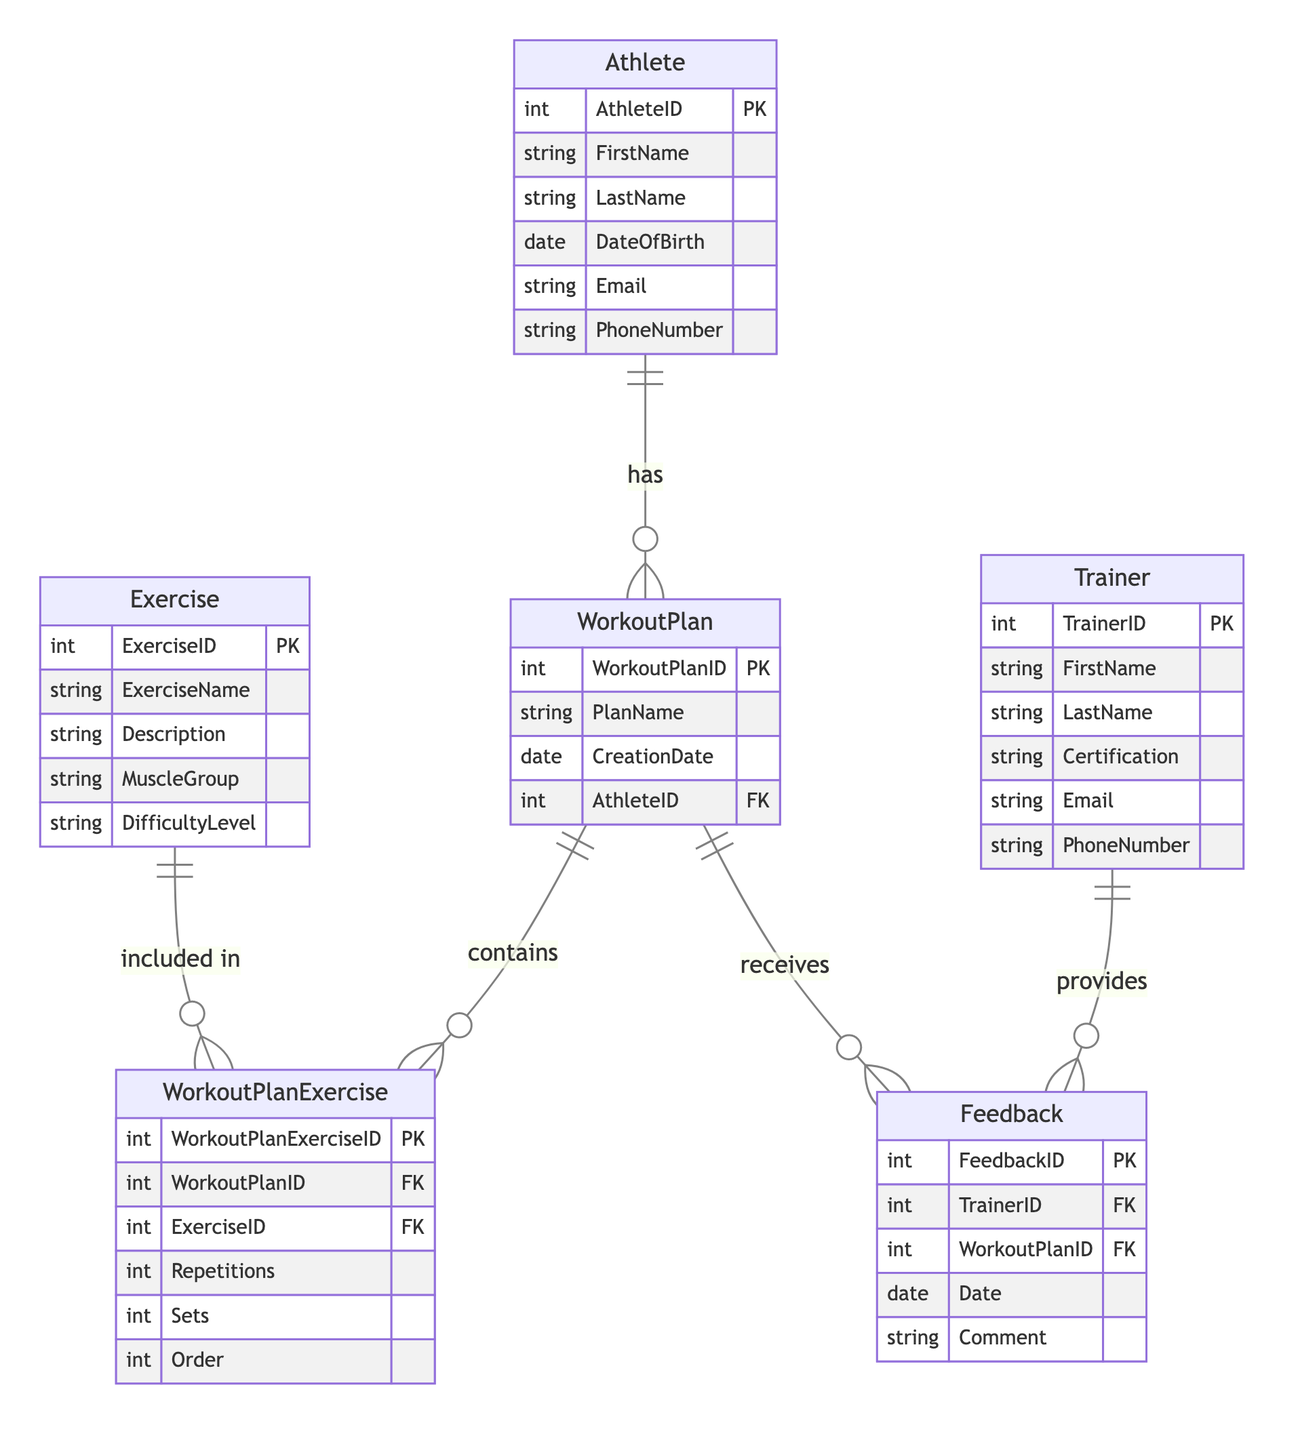What is the primary key of the Athlete entity? The primary key of the Athlete entity is AthleteID, as indicated in the attributes for the Athlete entity.
Answer: AthleteID How many attributes does the Exercise entity have? The Exercise entity has five attributes: ExerciseID, ExerciseName, Description, MuscleGroup, and DifficultyLevel. This can be verified by counting the entries in the Exercise attributes list.
Answer: Five What type of relationship exists between WorkoutPlan and Exercise? The relationship between WorkoutPlan and Exercise is many-to-many, as denoted in the relationships section that specifies they are connected through the WorkoutPlanExercise entity.
Answer: Many-to-many Which entity receives feedback? The WorkoutPlan entity receives feedback, as indicated in the relationship showing that Feedback is received by WorkoutPlan.
Answer: WorkoutPlan What is the foreign key in the WorkoutPlan entity? The foreign key in the WorkoutPlan entity is AthleteID, which establishes a link to the Athlete entity. This is specified in the attributes for WorkoutPlan.
Answer: AthleteID How many feedback entries can a Trainer provide? A Trainer can provide multiple feedback entries because there is a one-to-many relationship between the Trainer and Feedback entities, which allows for this type of connection.
Answer: Many What does the Order attribute in WorkoutPlanExercise represent? The Order attribute in WorkoutPlanExercise represents the sequence in which the exercises are organized within a workout plan, indicating the preference for execution. This understanding is derived from the context of the WorkoutPlanExercise entity's attributes.
Answer: Sequence Is the Exercise entity related directly to the Athlete entity? No, the Exercise entity is not directly related to the Athlete entity; it is related through the WorkoutPlan and WorkoutPlanExercise entities as depicted in the diagram relationships.
Answer: No What type of document provides comments to Feedback? The Feedback entity includes comments provided by the Trainer; this is demonstrated in the attributes of the Feedback entity where the Comment attribute is included.
Answer: Comments 